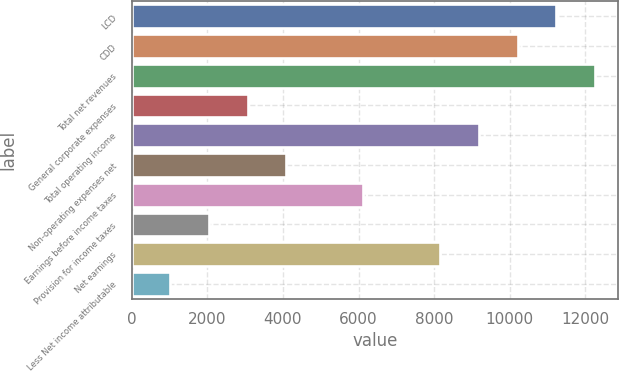<chart> <loc_0><loc_0><loc_500><loc_500><bar_chart><fcel>LCD<fcel>CDD<fcel>Total net revenues<fcel>General corporate expenses<fcel>Total operating income<fcel>Non-operating expenses net<fcel>Earnings before income taxes<fcel>Provision for income taxes<fcel>Net earnings<fcel>Less Net income attributable<nl><fcel>11226.4<fcel>10205.9<fcel>12246.8<fcel>3062.61<fcel>9185.43<fcel>4083.08<fcel>6124.02<fcel>2042.14<fcel>8164.96<fcel>1021.67<nl></chart> 